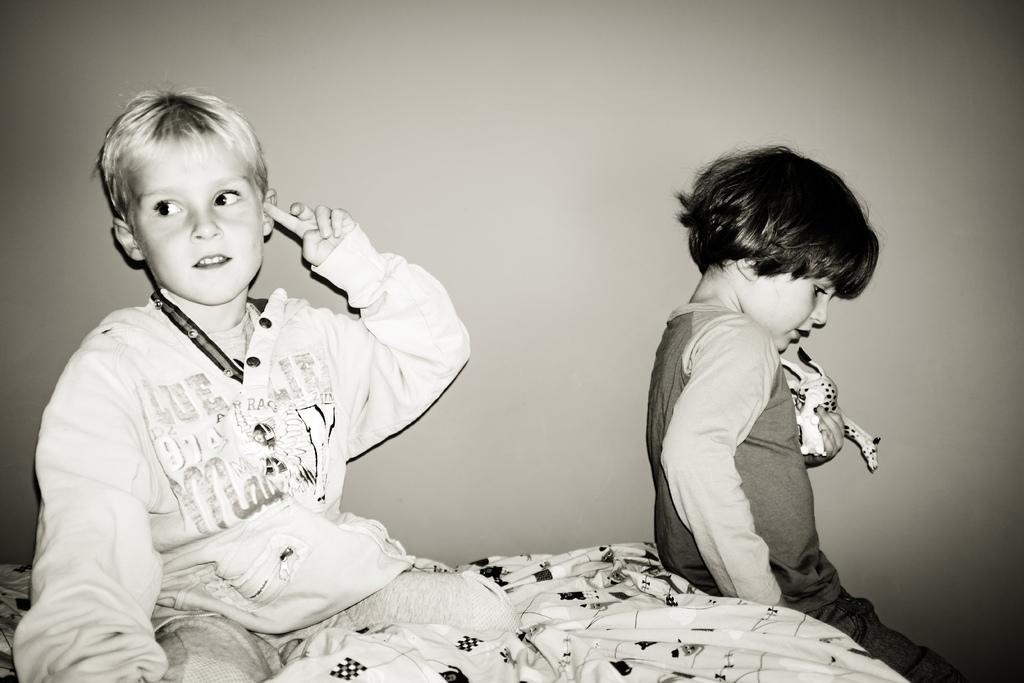In one or two sentences, can you explain what this image depicts? In this picture I see 2 children who are sitting and I see that this child is holding a thing and in the background I see the wall and I see that this is a white and black image. 